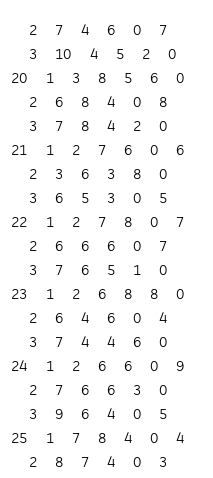Convert code to text. <code><loc_0><loc_0><loc_500><loc_500><_ObjectiveC_>	2	7	4	6	0	7	
	3	10	4	5	2	0	
20	1	3	8	5	6	0	
	2	6	8	4	0	8	
	3	7	8	4	2	0	
21	1	2	7	6	0	6	
	2	3	6	3	8	0	
	3	6	5	3	0	5	
22	1	2	7	8	0	7	
	2	6	6	6	0	7	
	3	7	6	5	1	0	
23	1	2	6	8	8	0	
	2	6	4	6	0	4	
	3	7	4	4	6	0	
24	1	2	6	6	0	9	
	2	7	6	6	3	0	
	3	9	6	4	0	5	
25	1	7	8	4	0	4	
	2	8	7	4	0	3	</code> 